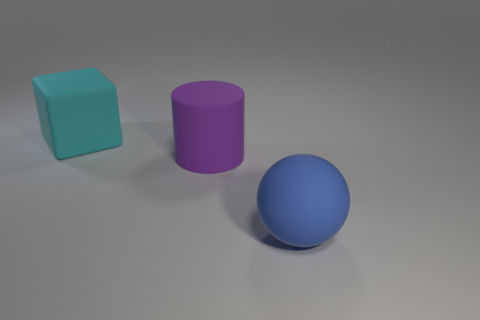What is the lightning condition of the scene? The lighting in the scene appears to be soft and diffused, with no harsh shadows or bright highlights, suggesting an evenly lit environment, possibly with a single source of light placed above the objects. 